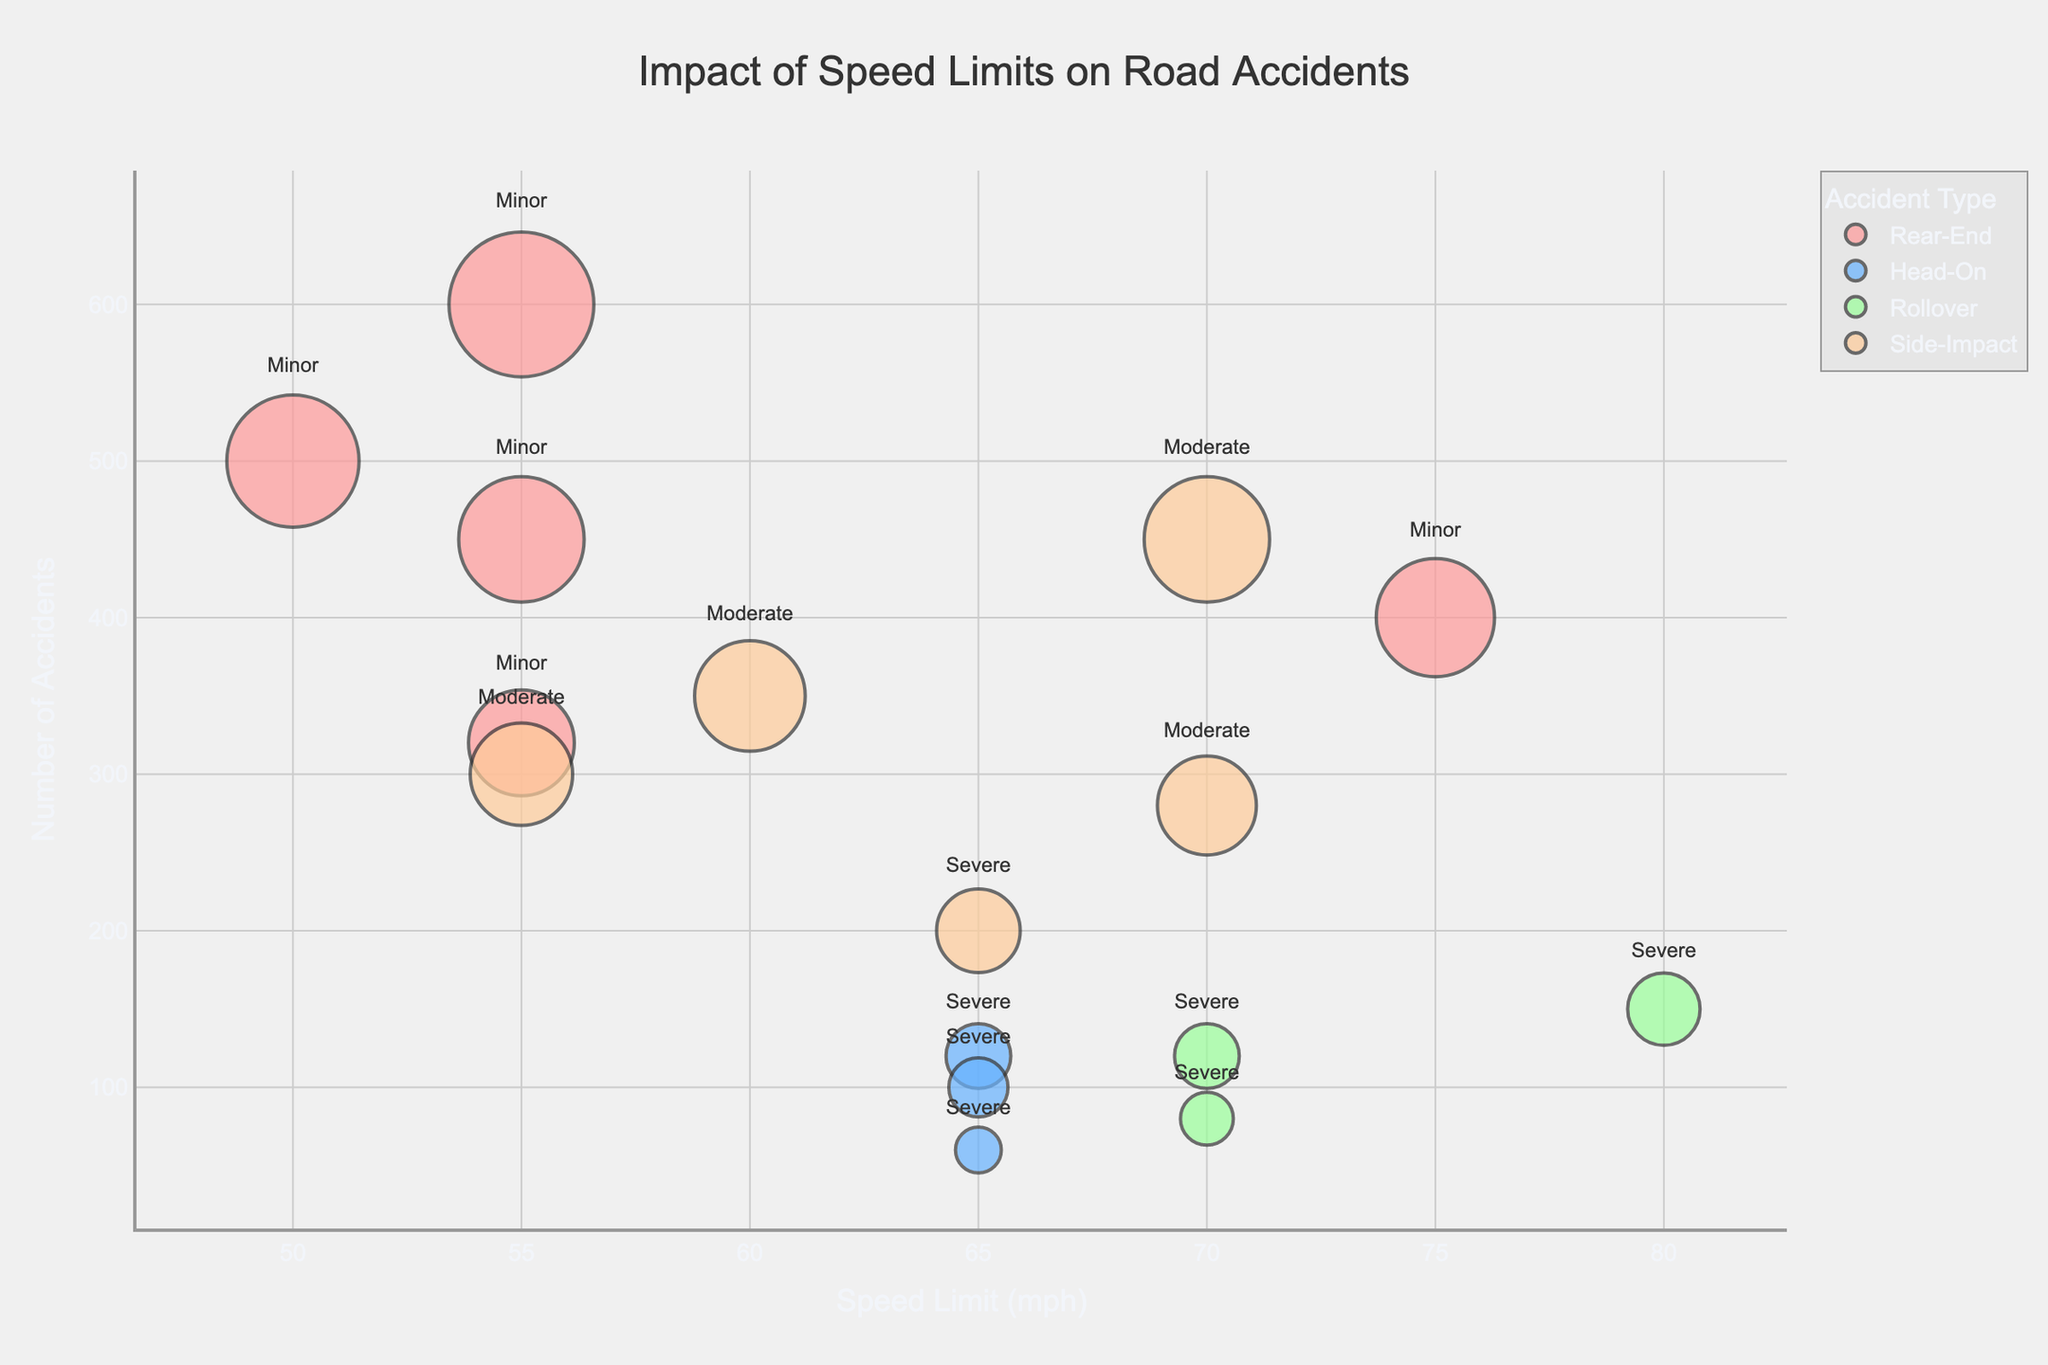How many regions are represented in the figure? To find the number of regions in the figure, look at the different hover names indicated by the bubbles. Each hover name corresponds to a different region: California, New York, Texas, Florida, and Washington. Count these regions.
Answer: 5 Which Speed Limit has the highest number of accidents? Observe the x-axis for speed limits and identify the bubble with the highest placement on the y-axis, which denotes the number of accidents. The highest point on the y-axis is at 55 mph, which is represented by the bubble at 600 indicating the number of accidents.
Answer: 55 mph What is the severity level for the smallest bubble in Florida? Locate the smallest bubble in the figure that belongs to the hover name "Florida." The smallest bubble, based on size, is at the coordinates where the Speed Limit is 70 mph and the number of accidents is 120. Check the text on the bubble for severity, which in this case reads "Severe."
Answer: Severe Which region has the highest number of side-impact accidents at 70 mph? To answer this, identify the side-impact accidents represented by the color coding. Look for bubbles along the x-axis at 70 mph for each region and compare their sizes. Texas has the largest bubble for side-impact accidents at 70 mph with 450 accidents.
Answer: Texas Compare the number of rollover accidents at 70 mph between California and Florida. Look at the bubbles that correspond to rollover accidents placed at 70 mph on the x-axis. California has a bubble with 80 rollover accidents, while Florida has a bubble with 120 rollover accidents. Compare these numbers.
Answer: Florida has more What is the total number of severe accidents in Texas? To find this, identify all bubbles tagged with Texas in the hover name and marked with "Severe" severity text. There are two bubbles: rollover at 80 mph with 150 accidents and no other severe accident type. Sum these accident numbers: 150.
Answer: 150 Which accident type has the highest number of incidents in New York? To determine this, check the color-coded bubbles for the region New York and compare their sizes. Rear-End accidents (at 50 mph) have the largest bubble with 500 incidents.
Answer: Rear-End How many moderate severity accidents occur at 55 mph and in which states? Identify bubbles at the 55 mph speed limit with "Moderate" written on them. There is one moderate severity accident bubble at 55 mph in California. So, California has 300 such accidents.
Answer: California has 300 What is the average number of rear-end accidents across all regions? Locate all the bubbles representing rear-end accidents across the speed limits. Sum their numbers: 450 + 500 + 400 + 600 + 320 = 2270. Divide by the number of regions for rear-end accidents (5): 2270/5 = 454.
Answer: 454 Describe the trend of minor severity accidents with increasing speed limits. Observe the bubbles with "Minor" severity text and track their positions along the speed limit axis. Notice that most minor accidents occur at lower speed limits (55 mph) and there are significant bubbles at these speed limits, indicating a high number of accidents. As speed limits increase, the size of minor severity bubbles generally decreases.
Answer: Decreasing 